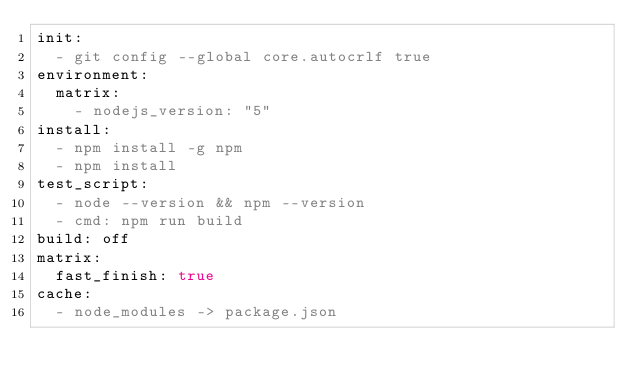<code> <loc_0><loc_0><loc_500><loc_500><_YAML_>init:
  - git config --global core.autocrlf true
environment:
  matrix:
    - nodejs_version: "5"
install:
  - npm install -g npm
  - npm install
test_script:
  - node --version && npm --version
  - cmd: npm run build
build: off
matrix:
  fast_finish: true
cache:
  - node_modules -> package.json
</code> 